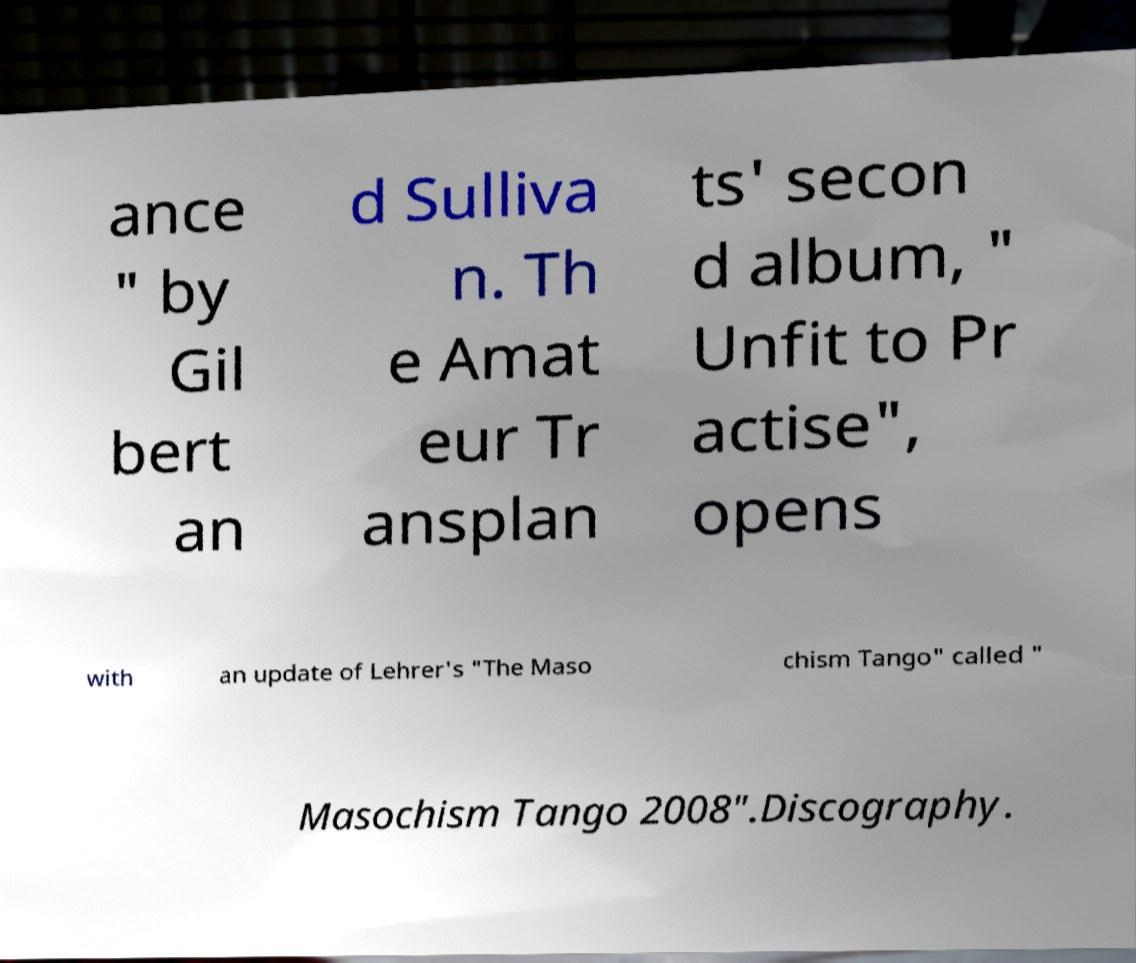I need the written content from this picture converted into text. Can you do that? ance " by Gil bert an d Sulliva n. Th e Amat eur Tr ansplan ts' secon d album, " Unfit to Pr actise", opens with an update of Lehrer's "The Maso chism Tango" called " Masochism Tango 2008".Discography. 